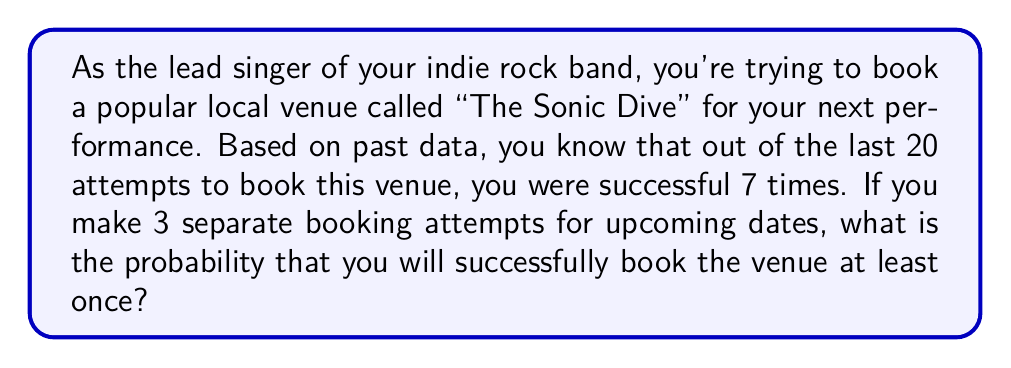Show me your answer to this math problem. Let's approach this step-by-step:

1) First, we need to calculate the probability of successfully booking the venue on a single attempt:

   $P(\text{success}) = \frac{7}{20} = 0.35$ or 35%

2) The probability of not booking the venue on a single attempt is:

   $P(\text{failure}) = 1 - P(\text{success}) = 1 - 0.35 = 0.65$ or 65%

3) Now, we want to find the probability of booking the venue at least once in 3 attempts. It's easier to calculate the probability of failing all 3 times and then subtract that from 1:

   $P(\text{at least one success}) = 1 - P(\text{all failures})$

4) The probability of failing all 3 times is:

   $P(\text{all failures}) = 0.65 \times 0.65 \times 0.65 = 0.65^3 \approx 0.2746$

5) Therefore, the probability of booking the venue at least once in 3 attempts is:

   $P(\text{at least one success}) = 1 - 0.2746 = 0.7254$

6) Converting to a percentage:

   $0.7254 \times 100\% \approx 72.54\%$
Answer: The probability of successfully booking "The Sonic Dive" at least once in 3 attempts is approximately 72.54%. 